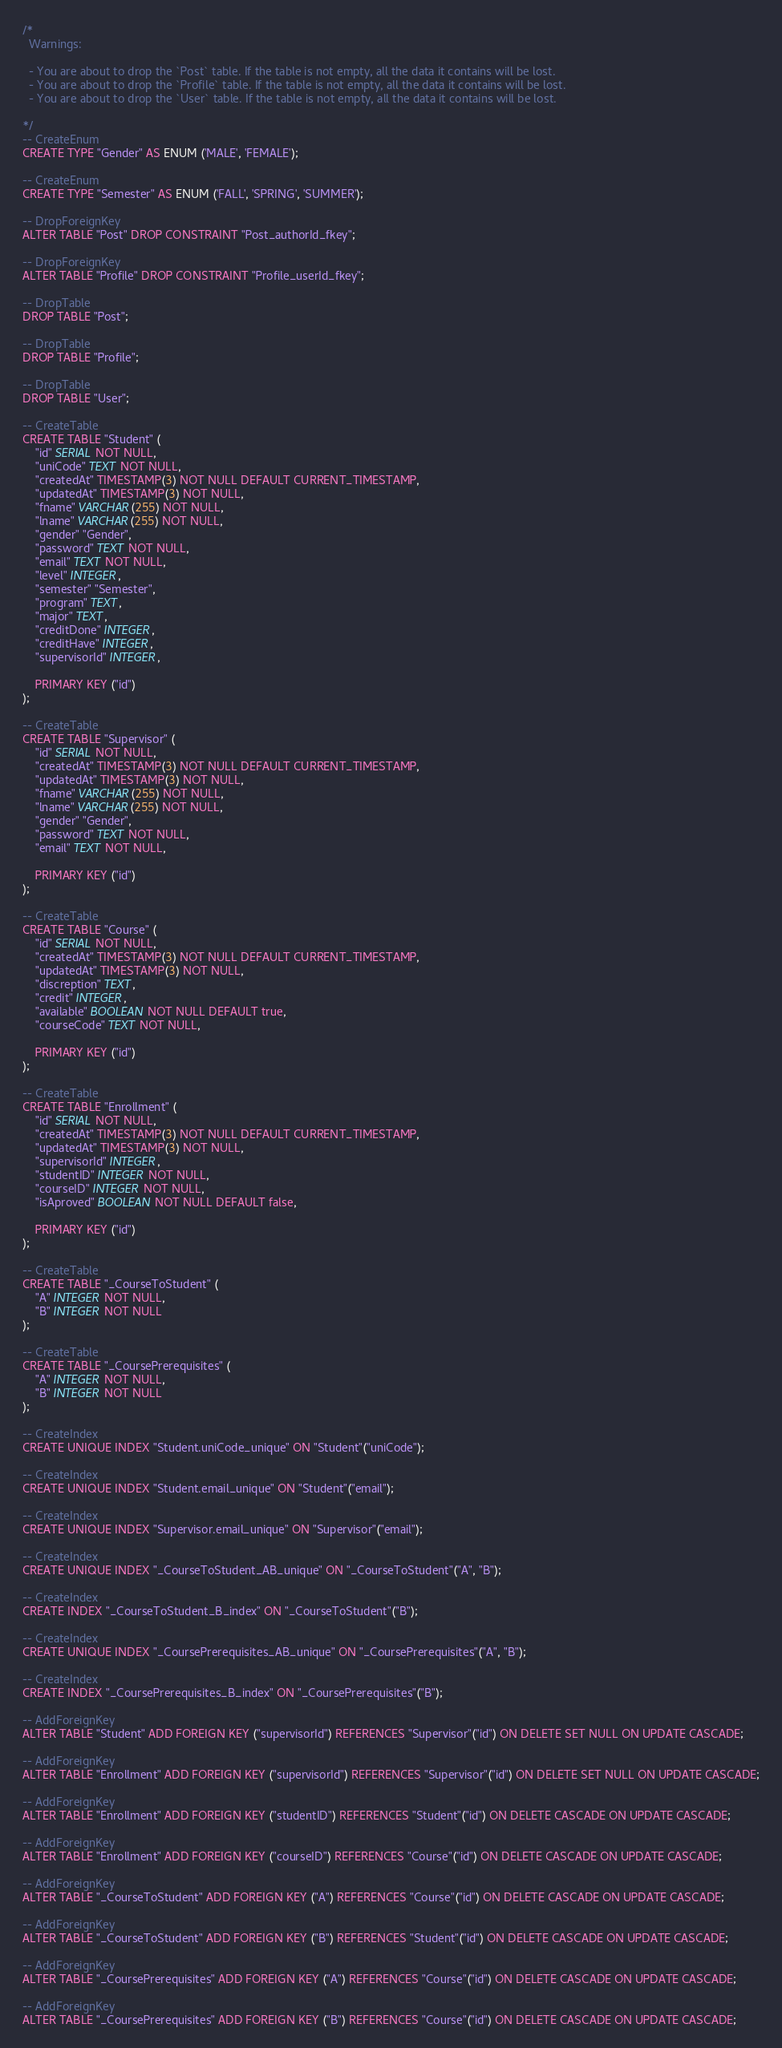<code> <loc_0><loc_0><loc_500><loc_500><_SQL_>/*
  Warnings:

  - You are about to drop the `Post` table. If the table is not empty, all the data it contains will be lost.
  - You are about to drop the `Profile` table. If the table is not empty, all the data it contains will be lost.
  - You are about to drop the `User` table. If the table is not empty, all the data it contains will be lost.

*/
-- CreateEnum
CREATE TYPE "Gender" AS ENUM ('MALE', 'FEMALE');

-- CreateEnum
CREATE TYPE "Semester" AS ENUM ('FALL', 'SPRING', 'SUMMER');

-- DropForeignKey
ALTER TABLE "Post" DROP CONSTRAINT "Post_authorId_fkey";

-- DropForeignKey
ALTER TABLE "Profile" DROP CONSTRAINT "Profile_userId_fkey";

-- DropTable
DROP TABLE "Post";

-- DropTable
DROP TABLE "Profile";

-- DropTable
DROP TABLE "User";

-- CreateTable
CREATE TABLE "Student" (
    "id" SERIAL NOT NULL,
    "uniCode" TEXT NOT NULL,
    "createdAt" TIMESTAMP(3) NOT NULL DEFAULT CURRENT_TIMESTAMP,
    "updatedAt" TIMESTAMP(3) NOT NULL,
    "fname" VARCHAR(255) NOT NULL,
    "lname" VARCHAR(255) NOT NULL,
    "gender" "Gender",
    "password" TEXT NOT NULL,
    "email" TEXT NOT NULL,
    "level" INTEGER,
    "semester" "Semester",
    "program" TEXT,
    "major" TEXT,
    "creditDone" INTEGER,
    "creditHave" INTEGER,
    "supervisorId" INTEGER,

    PRIMARY KEY ("id")
);

-- CreateTable
CREATE TABLE "Supervisor" (
    "id" SERIAL NOT NULL,
    "createdAt" TIMESTAMP(3) NOT NULL DEFAULT CURRENT_TIMESTAMP,
    "updatedAt" TIMESTAMP(3) NOT NULL,
    "fname" VARCHAR(255) NOT NULL,
    "lname" VARCHAR(255) NOT NULL,
    "gender" "Gender",
    "password" TEXT NOT NULL,
    "email" TEXT NOT NULL,

    PRIMARY KEY ("id")
);

-- CreateTable
CREATE TABLE "Course" (
    "id" SERIAL NOT NULL,
    "createdAt" TIMESTAMP(3) NOT NULL DEFAULT CURRENT_TIMESTAMP,
    "updatedAt" TIMESTAMP(3) NOT NULL,
    "discreption" TEXT,
    "credit" INTEGER,
    "available" BOOLEAN NOT NULL DEFAULT true,
    "courseCode" TEXT NOT NULL,

    PRIMARY KEY ("id")
);

-- CreateTable
CREATE TABLE "Enrollment" (
    "id" SERIAL NOT NULL,
    "createdAt" TIMESTAMP(3) NOT NULL DEFAULT CURRENT_TIMESTAMP,
    "updatedAt" TIMESTAMP(3) NOT NULL,
    "supervisorId" INTEGER,
    "studentID" INTEGER NOT NULL,
    "courseID" INTEGER NOT NULL,
    "isAproved" BOOLEAN NOT NULL DEFAULT false,

    PRIMARY KEY ("id")
);

-- CreateTable
CREATE TABLE "_CourseToStudent" (
    "A" INTEGER NOT NULL,
    "B" INTEGER NOT NULL
);

-- CreateTable
CREATE TABLE "_CoursePrerequisites" (
    "A" INTEGER NOT NULL,
    "B" INTEGER NOT NULL
);

-- CreateIndex
CREATE UNIQUE INDEX "Student.uniCode_unique" ON "Student"("uniCode");

-- CreateIndex
CREATE UNIQUE INDEX "Student.email_unique" ON "Student"("email");

-- CreateIndex
CREATE UNIQUE INDEX "Supervisor.email_unique" ON "Supervisor"("email");

-- CreateIndex
CREATE UNIQUE INDEX "_CourseToStudent_AB_unique" ON "_CourseToStudent"("A", "B");

-- CreateIndex
CREATE INDEX "_CourseToStudent_B_index" ON "_CourseToStudent"("B");

-- CreateIndex
CREATE UNIQUE INDEX "_CoursePrerequisites_AB_unique" ON "_CoursePrerequisites"("A", "B");

-- CreateIndex
CREATE INDEX "_CoursePrerequisites_B_index" ON "_CoursePrerequisites"("B");

-- AddForeignKey
ALTER TABLE "Student" ADD FOREIGN KEY ("supervisorId") REFERENCES "Supervisor"("id") ON DELETE SET NULL ON UPDATE CASCADE;

-- AddForeignKey
ALTER TABLE "Enrollment" ADD FOREIGN KEY ("supervisorId") REFERENCES "Supervisor"("id") ON DELETE SET NULL ON UPDATE CASCADE;

-- AddForeignKey
ALTER TABLE "Enrollment" ADD FOREIGN KEY ("studentID") REFERENCES "Student"("id") ON DELETE CASCADE ON UPDATE CASCADE;

-- AddForeignKey
ALTER TABLE "Enrollment" ADD FOREIGN KEY ("courseID") REFERENCES "Course"("id") ON DELETE CASCADE ON UPDATE CASCADE;

-- AddForeignKey
ALTER TABLE "_CourseToStudent" ADD FOREIGN KEY ("A") REFERENCES "Course"("id") ON DELETE CASCADE ON UPDATE CASCADE;

-- AddForeignKey
ALTER TABLE "_CourseToStudent" ADD FOREIGN KEY ("B") REFERENCES "Student"("id") ON DELETE CASCADE ON UPDATE CASCADE;

-- AddForeignKey
ALTER TABLE "_CoursePrerequisites" ADD FOREIGN KEY ("A") REFERENCES "Course"("id") ON DELETE CASCADE ON UPDATE CASCADE;

-- AddForeignKey
ALTER TABLE "_CoursePrerequisites" ADD FOREIGN KEY ("B") REFERENCES "Course"("id") ON DELETE CASCADE ON UPDATE CASCADE;
</code> 